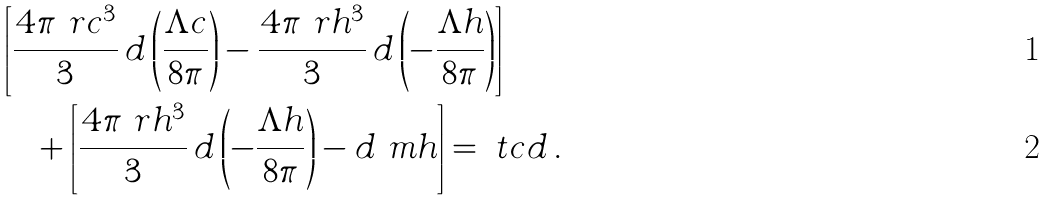Convert formula to latex. <formula><loc_0><loc_0><loc_500><loc_500>& \left [ \frac { 4 \pi \ r c ^ { 3 } } { 3 } \, d \left ( \frac { \Lambda c } { 8 \pi } \right ) - \frac { 4 \pi \ r h ^ { 3 } } { 3 } \, d \left ( - \frac { \Lambda h } { 8 \pi } \right ) \right ] \\ & \quad + \left [ \frac { 4 \pi \ r h ^ { 3 } } { 3 } \, d \left ( - \frac { \Lambda h } { 8 \pi } \right ) - d \ m h \right ] = \ t c d \, .</formula> 